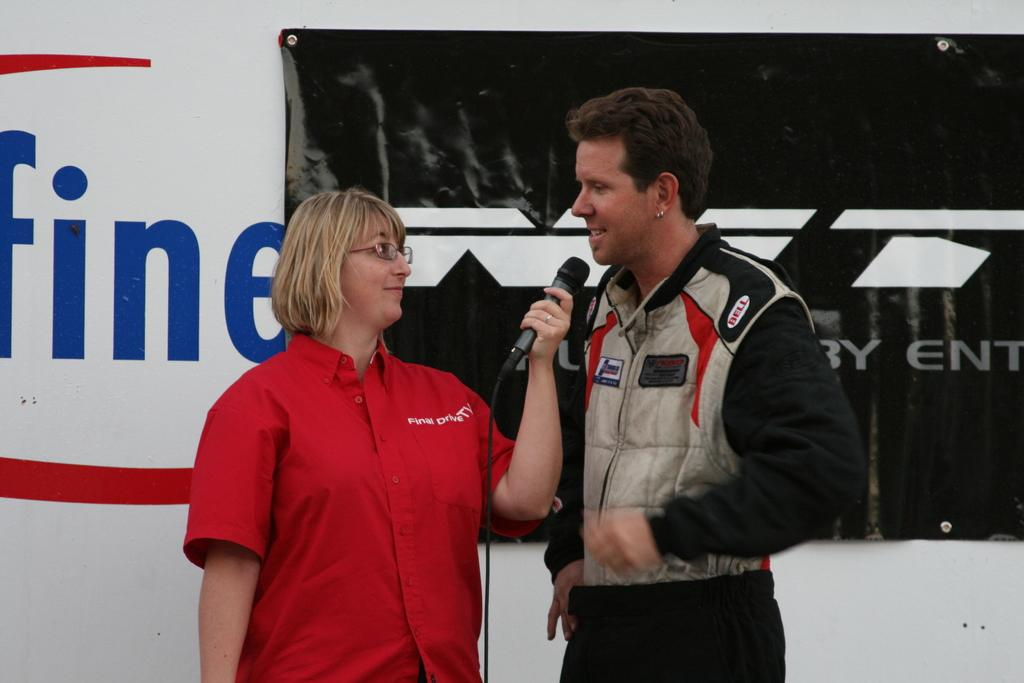How many people are in the image? There are two persons in the image. What are the persons doing in the image? The persons are standing on the floor. What is the left side person holding? The left side person is holding a microphone. What can be seen in the background of the image? There is a wall in the background of the image, and a banner is attached to the wall. What decision is being made by the person holding the bit in the image? There is no person holding a bit in the image, and therefore no decision-making process can be observed. 